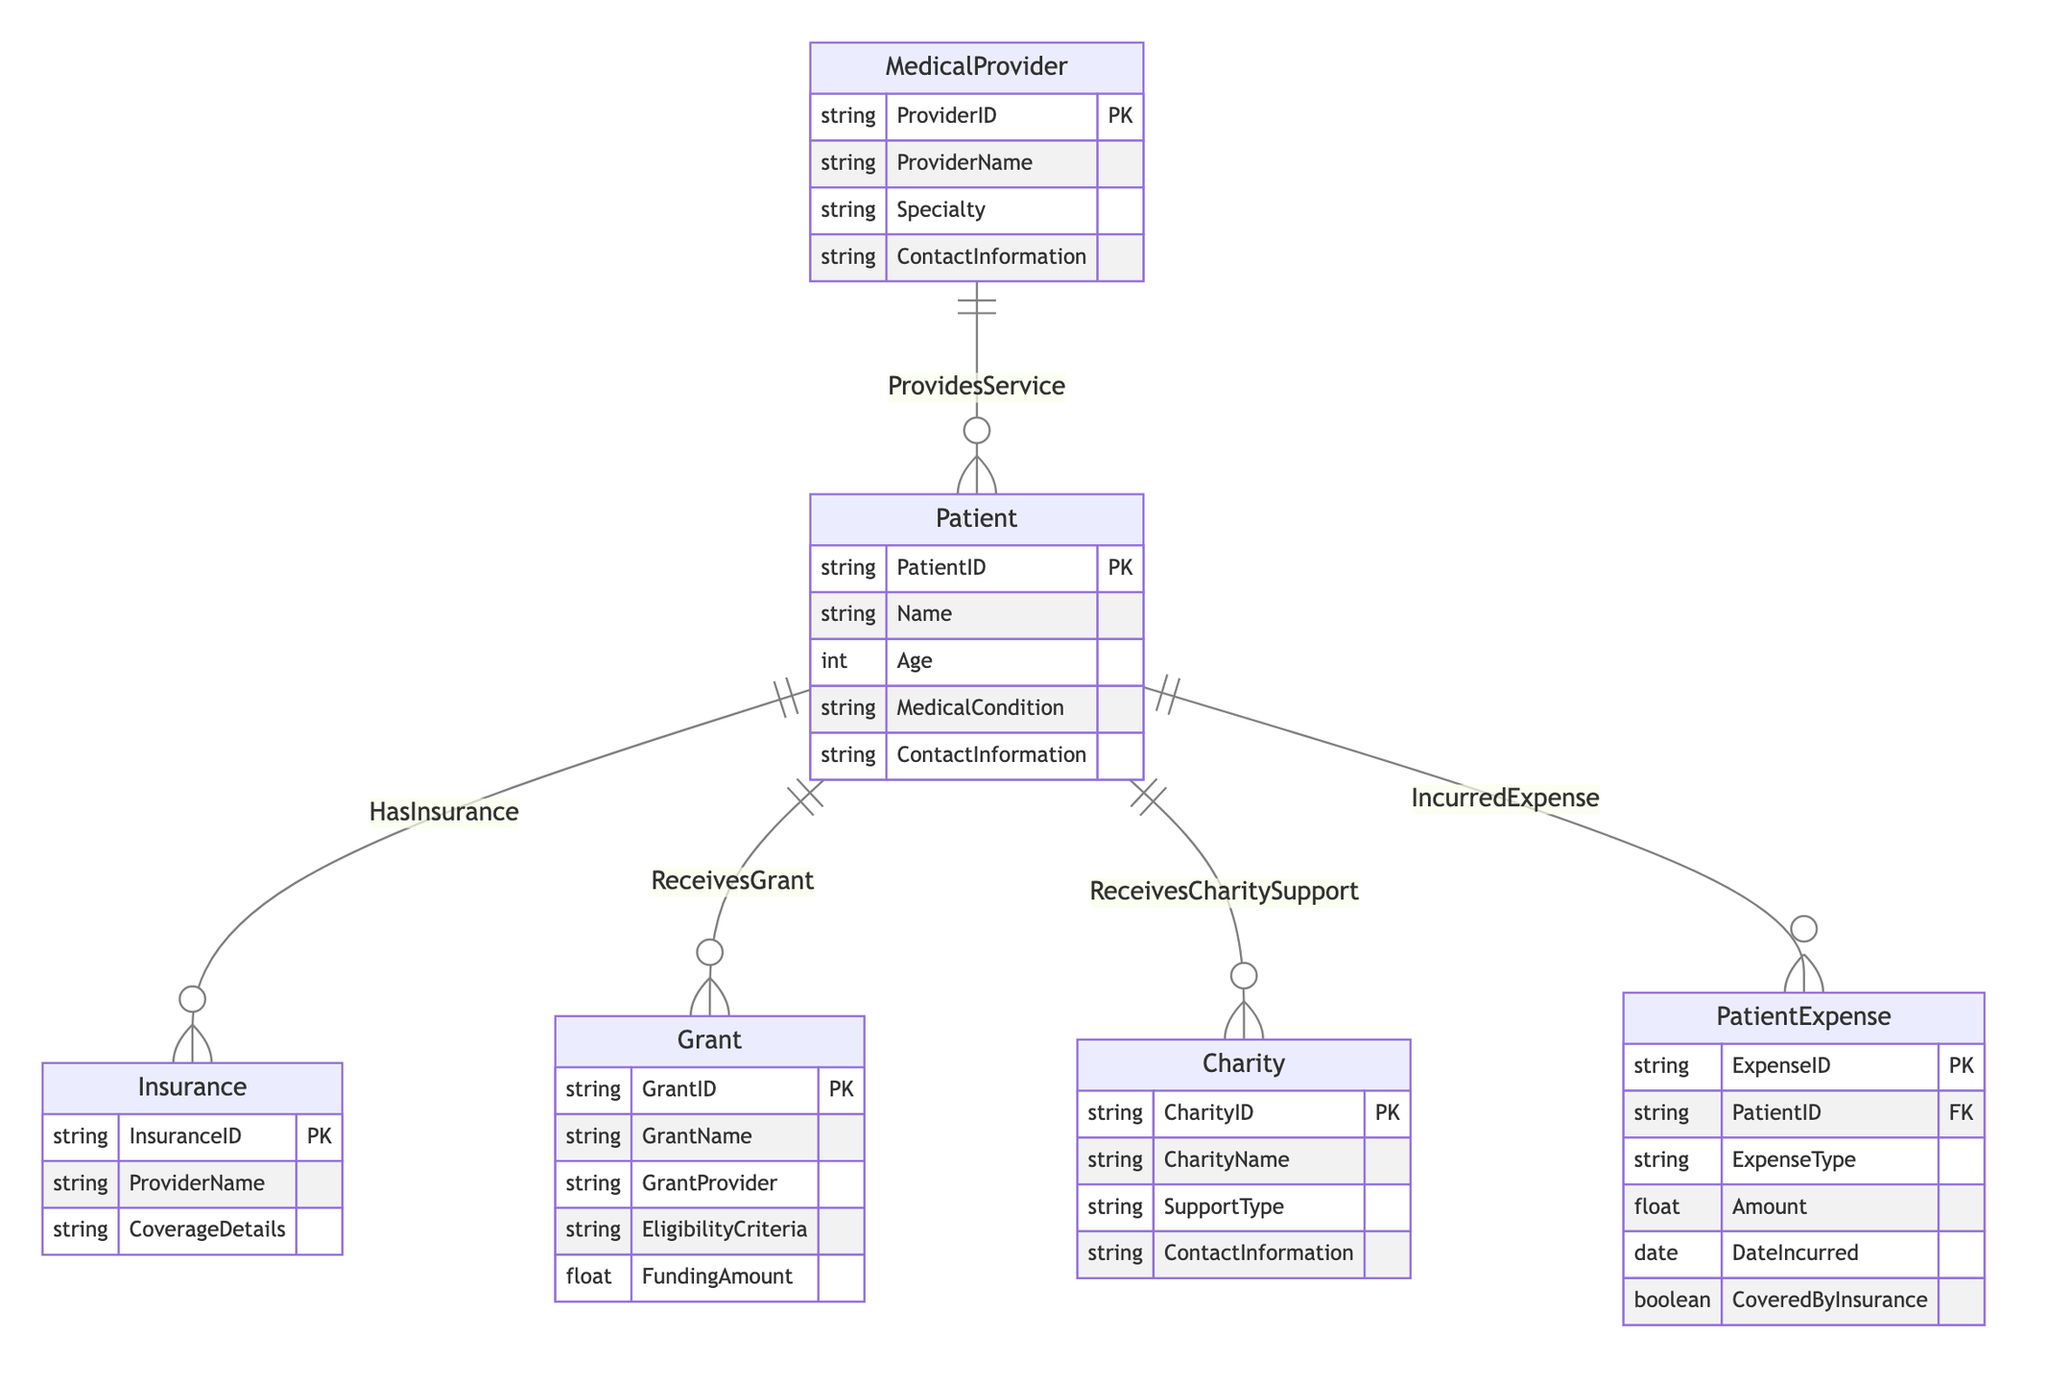What entities are included in the diagram? The diagram includes six main entities: Patient, Insurance, Grant, Charity, Medical Provider, and Patient Expense. These entities represent different aspects of financial assistance programs and their interactions with patients.
Answer: Patient, Insurance, Grant, Charity, Medical Provider, Patient Expense How many relationships are depicted in the diagram? The diagram shows five relationships connecting various entities. Each relationship illustrates how entities interact with one another, such as patients receiving grants or incurring expenses.
Answer: Five What is the relationship between Patient and Medical Provider? The relationship is labeled "ProvidesService," indicating that Medical Providers offer services to Patients. This signifies a direct connection where Patients receive care from Medical Providers.
Answer: ProvidesService What does the 'CoveredByInsurance' attribute indicate in Patient Expense? The 'CoveredByInsurance' attribute in Patient Expense indicates whether the incurred expense is covered by the patient's insurance. This information is crucial for understanding the financial burden on patients.
Answer: Whether the expense is covered Which entity can a Patient receive financial assistance from? A Patient can receive financial assistance from three entities: Grant, Charity, and Insurance. Each of these entities provides different types of financial support to help alleviate medical costs.
Answer: Grant, Charity, Insurance What type of information does the Insurance entity provide? The Insurance entity provides information including the InsuranceID, ProviderName, and CoverageDetails. This data helps describe the insurance coverage available to patients.
Answer: InsuranceID, ProviderName, CoverageDetails How are Grants connected to Patients? Grants are connected to Patients through the relationship labeled "ReceivesGrant." This indicates that patients may receive assistance based on specific eligibility criteria outlined by grant providers.
Answer: ReceivesGrant What required attributes would you find in the Charity entity? The Charity entity requires attributes such as CharityID, CharityName, SupportType, and ContactInformation. These attributes provide essential details about the charitable organization and the type of support it offers to patients.
Answer: CharityID, CharityName, SupportType, ContactInformation 